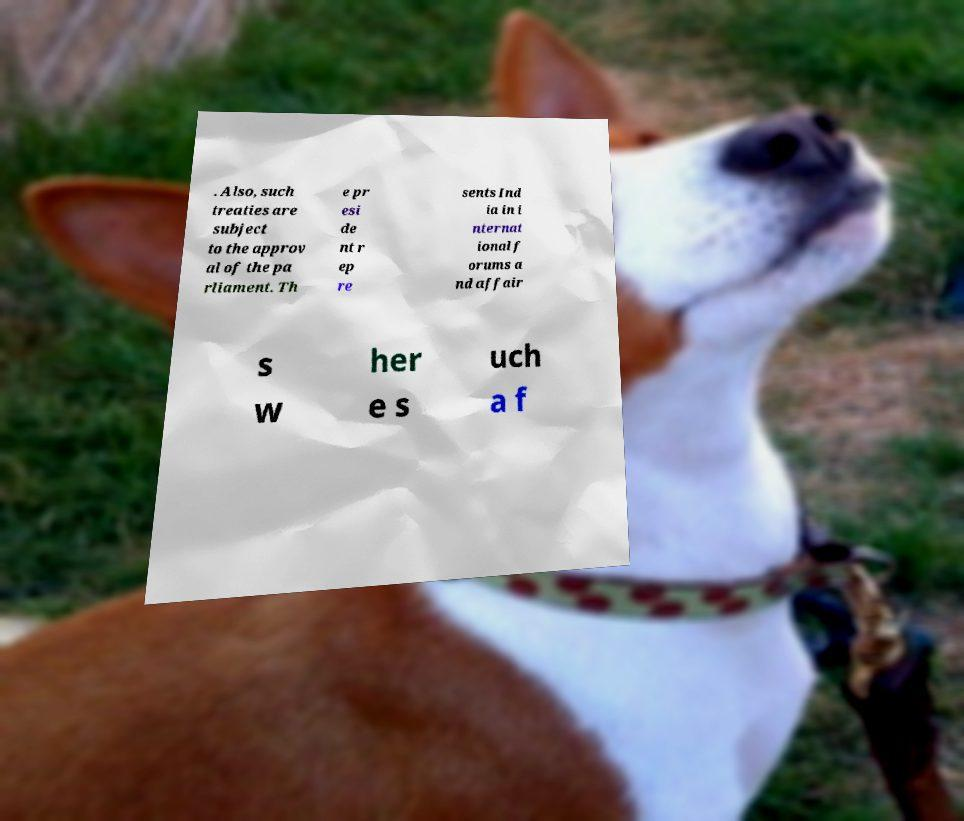Can you read and provide the text displayed in the image?This photo seems to have some interesting text. Can you extract and type it out for me? . Also, such treaties are subject to the approv al of the pa rliament. Th e pr esi de nt r ep re sents Ind ia in i nternat ional f orums a nd affair s w her e s uch a f 